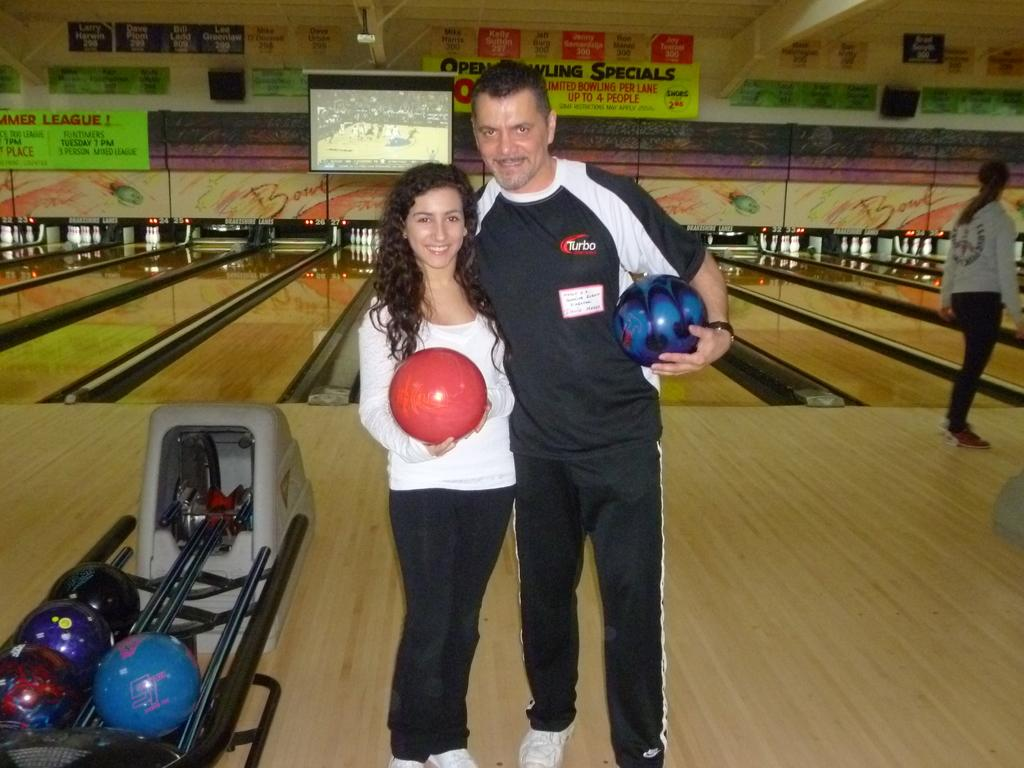<image>
Describe the image concisely. A bright sign tells people that the Open Bowling Specials allows up to 4 people to bowl in a lane. 